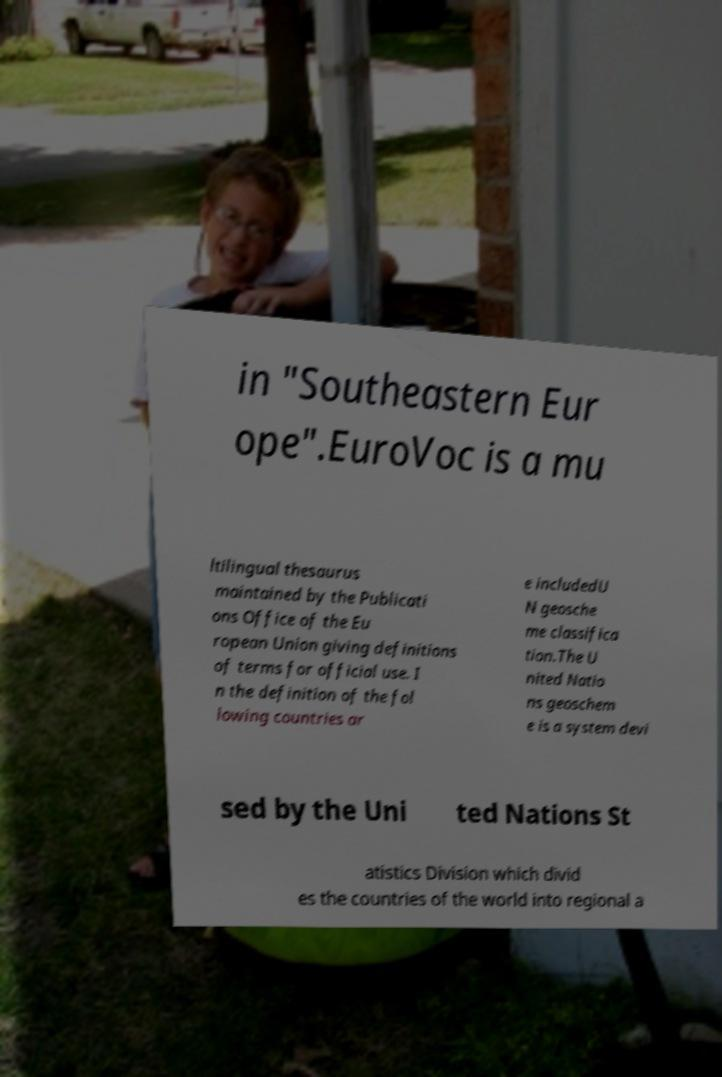Could you assist in decoding the text presented in this image and type it out clearly? in "Southeastern Eur ope".EuroVoc is a mu ltilingual thesaurus maintained by the Publicati ons Office of the Eu ropean Union giving definitions of terms for official use. I n the definition of the fol lowing countries ar e includedU N geosche me classifica tion.The U nited Natio ns geoschem e is a system devi sed by the Uni ted Nations St atistics Division which divid es the countries of the world into regional a 